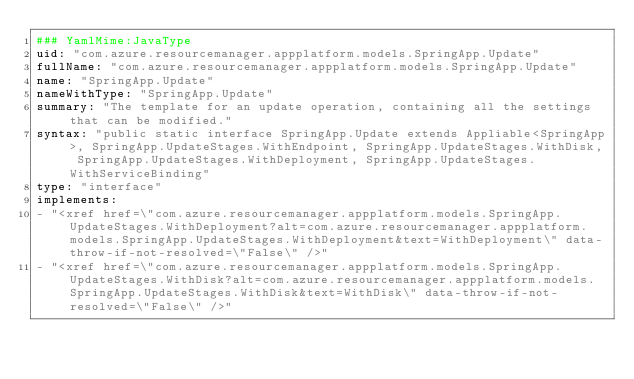<code> <loc_0><loc_0><loc_500><loc_500><_YAML_>### YamlMime:JavaType
uid: "com.azure.resourcemanager.appplatform.models.SpringApp.Update"
fullName: "com.azure.resourcemanager.appplatform.models.SpringApp.Update"
name: "SpringApp.Update"
nameWithType: "SpringApp.Update"
summary: "The template for an update operation, containing all the settings that can be modified."
syntax: "public static interface SpringApp.Update extends Appliable<SpringApp>, SpringApp.UpdateStages.WithEndpoint, SpringApp.UpdateStages.WithDisk, SpringApp.UpdateStages.WithDeployment, SpringApp.UpdateStages.WithServiceBinding"
type: "interface"
implements:
- "<xref href=\"com.azure.resourcemanager.appplatform.models.SpringApp.UpdateStages.WithDeployment?alt=com.azure.resourcemanager.appplatform.models.SpringApp.UpdateStages.WithDeployment&text=WithDeployment\" data-throw-if-not-resolved=\"False\" />"
- "<xref href=\"com.azure.resourcemanager.appplatform.models.SpringApp.UpdateStages.WithDisk?alt=com.azure.resourcemanager.appplatform.models.SpringApp.UpdateStages.WithDisk&text=WithDisk\" data-throw-if-not-resolved=\"False\" />"</code> 